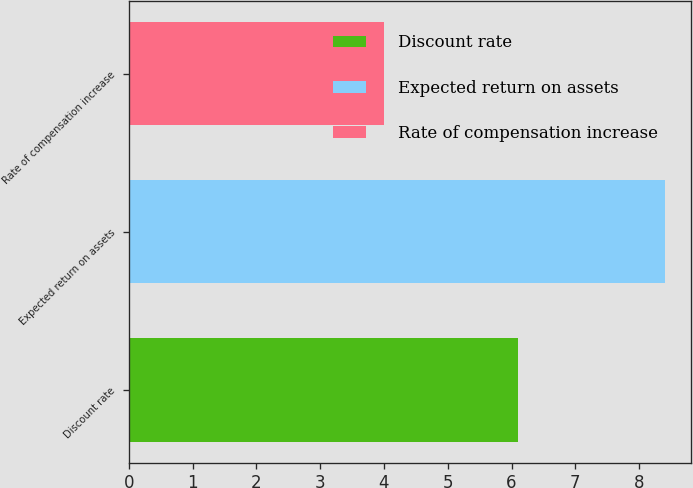<chart> <loc_0><loc_0><loc_500><loc_500><bar_chart><fcel>Discount rate<fcel>Expected return on assets<fcel>Rate of compensation increase<nl><fcel>6.1<fcel>8.4<fcel>4<nl></chart> 